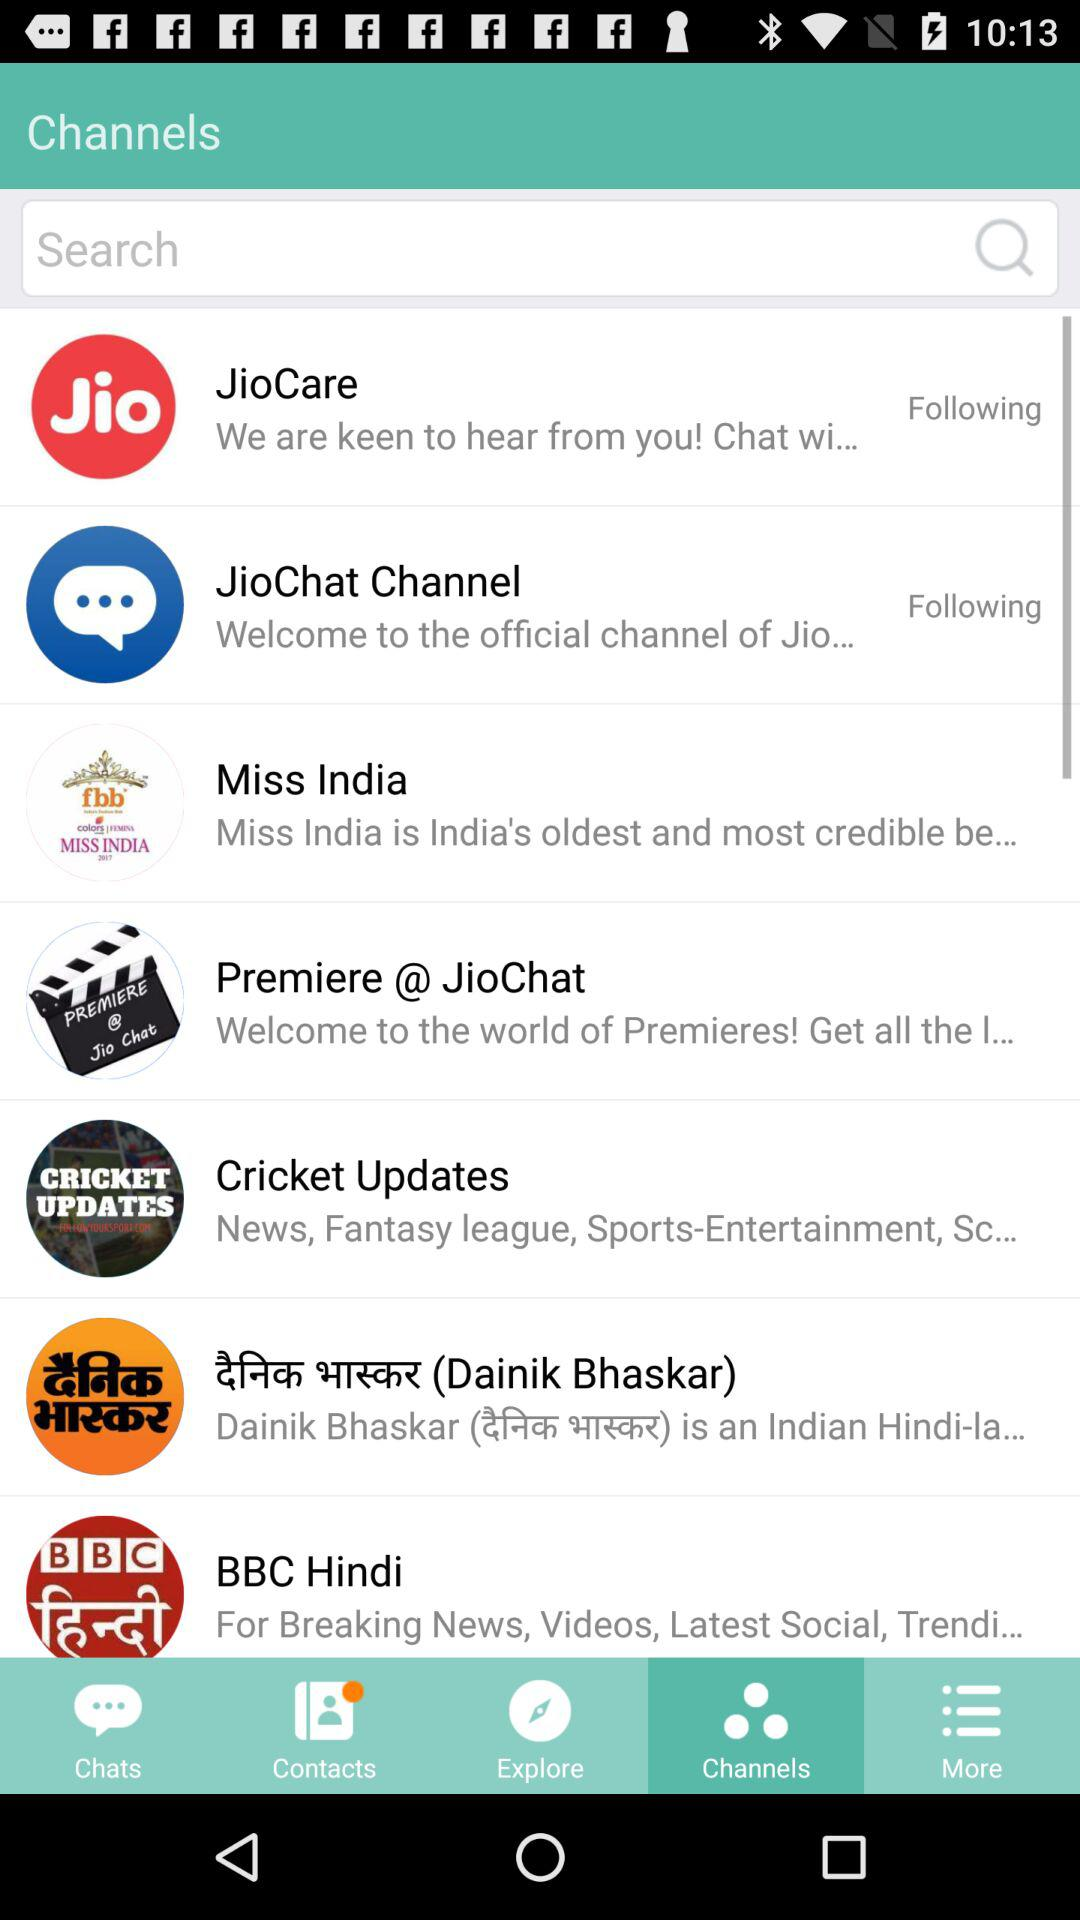What is the "BBC Hindi" application used for? The "BBC Hindi" application is used for "Breaking News, Videos, Latest Social, Trendi...". 